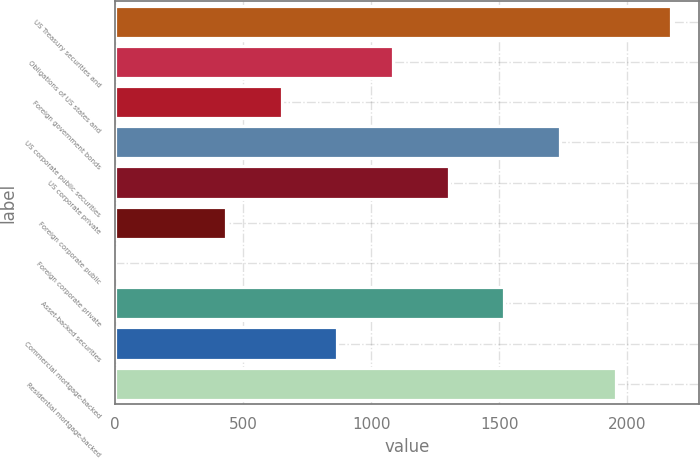Convert chart to OTSL. <chart><loc_0><loc_0><loc_500><loc_500><bar_chart><fcel>US Treasury securities and<fcel>Obligations of US states and<fcel>Foreign government bonds<fcel>US corporate public securities<fcel>US corporate private<fcel>Foreign corporate public<fcel>Foreign corporate private<fcel>Asset-backed securities<fcel>Commercial mortgage-backed<fcel>Residential mortgage-backed<nl><fcel>2170.98<fcel>1085.63<fcel>651.49<fcel>1736.84<fcel>1302.7<fcel>434.42<fcel>0.28<fcel>1519.77<fcel>868.56<fcel>1953.91<nl></chart> 